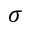<formula> <loc_0><loc_0><loc_500><loc_500>\sigma</formula> 